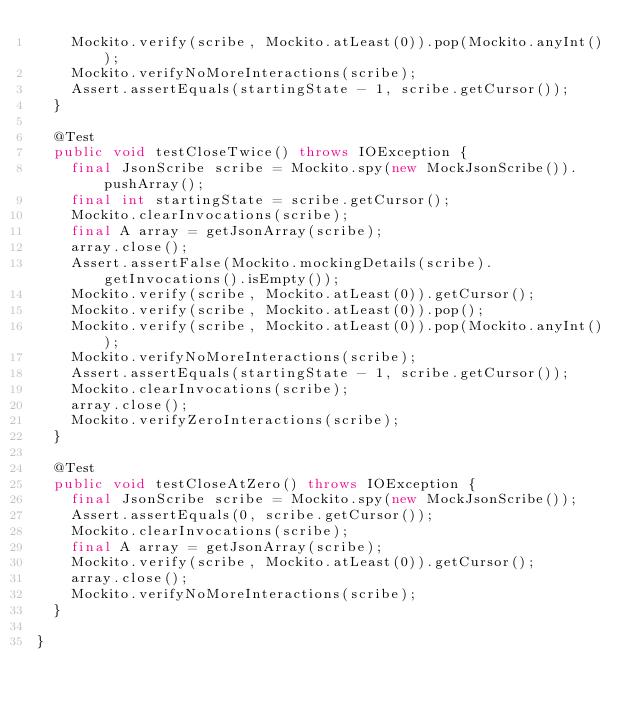Convert code to text. <code><loc_0><loc_0><loc_500><loc_500><_Java_>		Mockito.verify(scribe, Mockito.atLeast(0)).pop(Mockito.anyInt());
		Mockito.verifyNoMoreInteractions(scribe);
		Assert.assertEquals(startingState - 1, scribe.getCursor());
	}
	
	@Test
	public void testCloseTwice() throws IOException {
		final JsonScribe scribe = Mockito.spy(new MockJsonScribe()).pushArray();
		final int startingState = scribe.getCursor();
		Mockito.clearInvocations(scribe);
		final A array = getJsonArray(scribe);
		array.close();
		Assert.assertFalse(Mockito.mockingDetails(scribe).getInvocations().isEmpty());
		Mockito.verify(scribe, Mockito.atLeast(0)).getCursor();
		Mockito.verify(scribe, Mockito.atLeast(0)).pop();
		Mockito.verify(scribe, Mockito.atLeast(0)).pop(Mockito.anyInt());
		Mockito.verifyNoMoreInteractions(scribe);
		Assert.assertEquals(startingState - 1, scribe.getCursor());
		Mockito.clearInvocations(scribe);
		array.close();
		Mockito.verifyZeroInteractions(scribe);
	}
	
	@Test
	public void testCloseAtZero() throws IOException {
		final JsonScribe scribe = Mockito.spy(new MockJsonScribe());
		Assert.assertEquals(0, scribe.getCursor());
		Mockito.clearInvocations(scribe);
		final A array = getJsonArray(scribe);
		Mockito.verify(scribe, Mockito.atLeast(0)).getCursor();
		array.close();
		Mockito.verifyNoMoreInteractions(scribe);
	}
	
}
</code> 